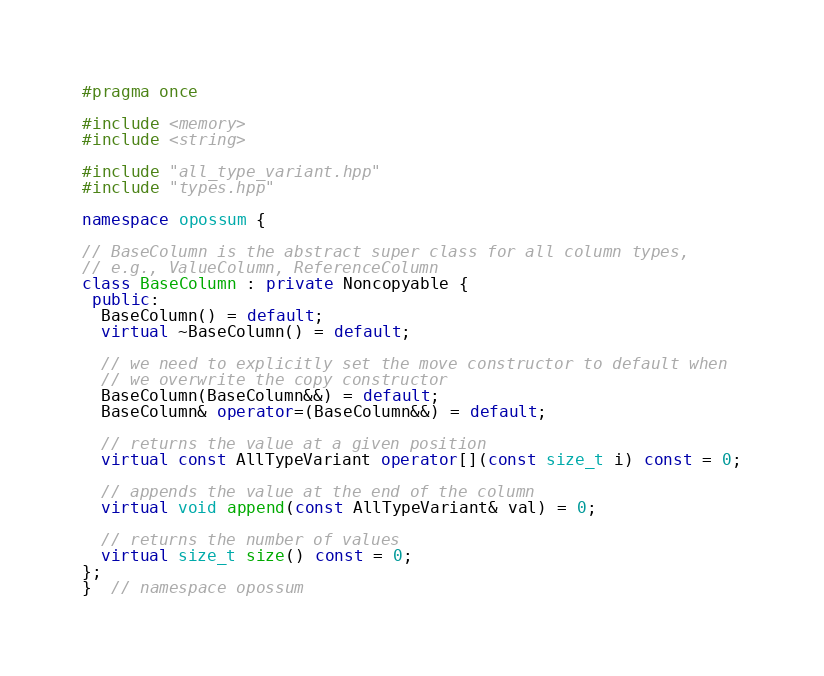Convert code to text. <code><loc_0><loc_0><loc_500><loc_500><_C++_>#pragma once

#include <memory>
#include <string>

#include "all_type_variant.hpp"
#include "types.hpp"

namespace opossum {

// BaseColumn is the abstract super class for all column types,
// e.g., ValueColumn, ReferenceColumn
class BaseColumn : private Noncopyable {
 public:
  BaseColumn() = default;
  virtual ~BaseColumn() = default;

  // we need to explicitly set the move constructor to default when
  // we overwrite the copy constructor
  BaseColumn(BaseColumn&&) = default;
  BaseColumn& operator=(BaseColumn&&) = default;

  // returns the value at a given position
  virtual const AllTypeVariant operator[](const size_t i) const = 0;

  // appends the value at the end of the column
  virtual void append(const AllTypeVariant& val) = 0;

  // returns the number of values
  virtual size_t size() const = 0;
};
}  // namespace opossum
</code> 